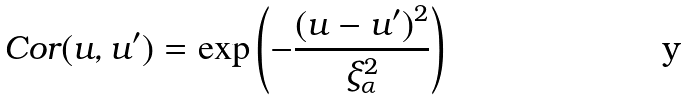<formula> <loc_0><loc_0><loc_500><loc_500>C o r ( u , u ^ { \prime } ) = \exp \left ( - \frac { ( u - u ^ { \prime } ) ^ { 2 } } { \xi _ { \alpha } ^ { 2 } } \right )</formula> 